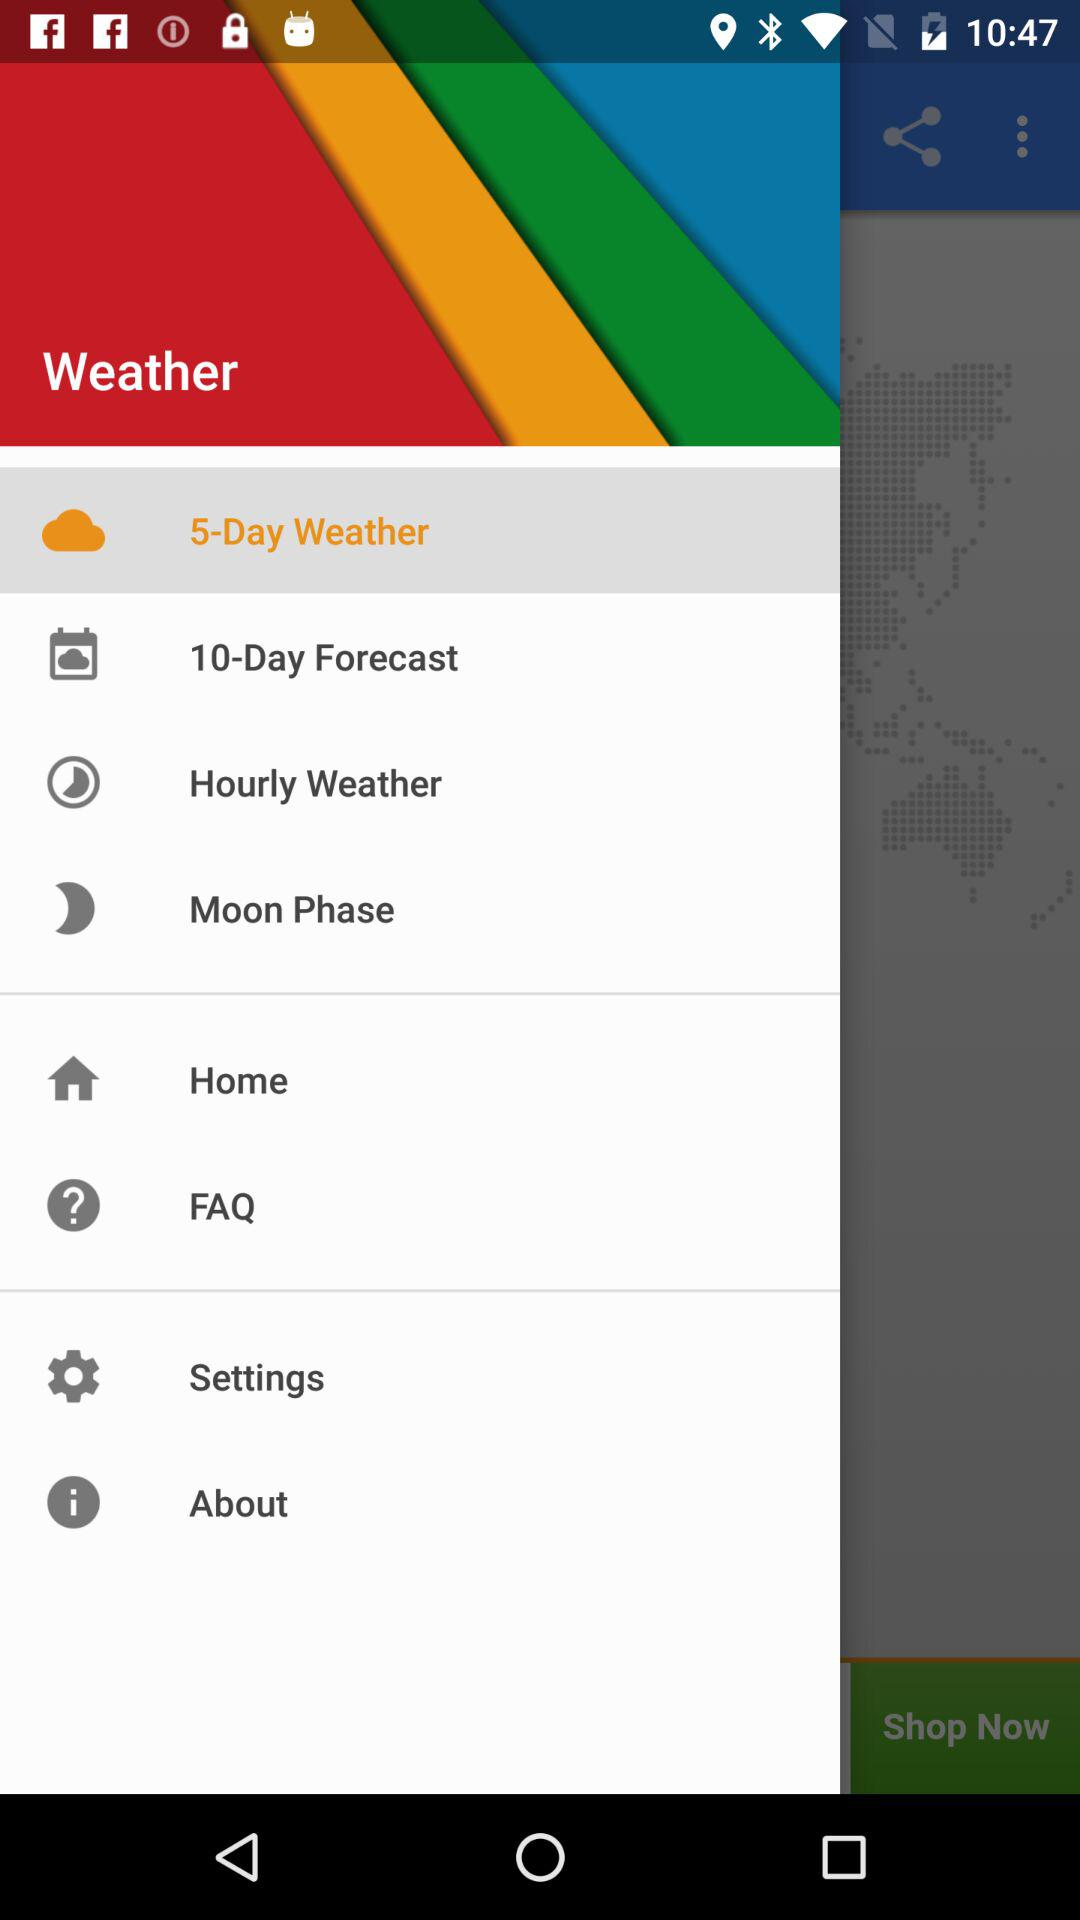Which option is selected? The selected option is "5-Day Weather". 